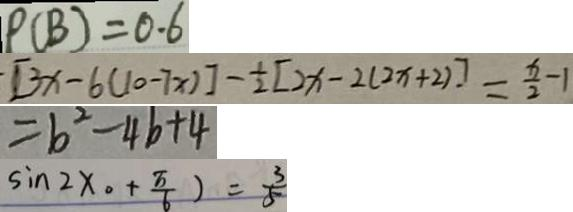Convert formula to latex. <formula><loc_0><loc_0><loc_500><loc_500>P ( B ) = 0 . 6 
 [ 3 x - 6 ( 1 0 - 7 x ) ] - \frac { 1 } { 2 } [ 2 x - 2 ( 2 x + 2 ) ] = \frac { x } { 2 } - 1 
 = b ^ { 2 } - 4 b + 4 
 \sin 2 x 。 + \frac { \pi } { 6 } ) = \frac { 3 } { 5 }</formula> 